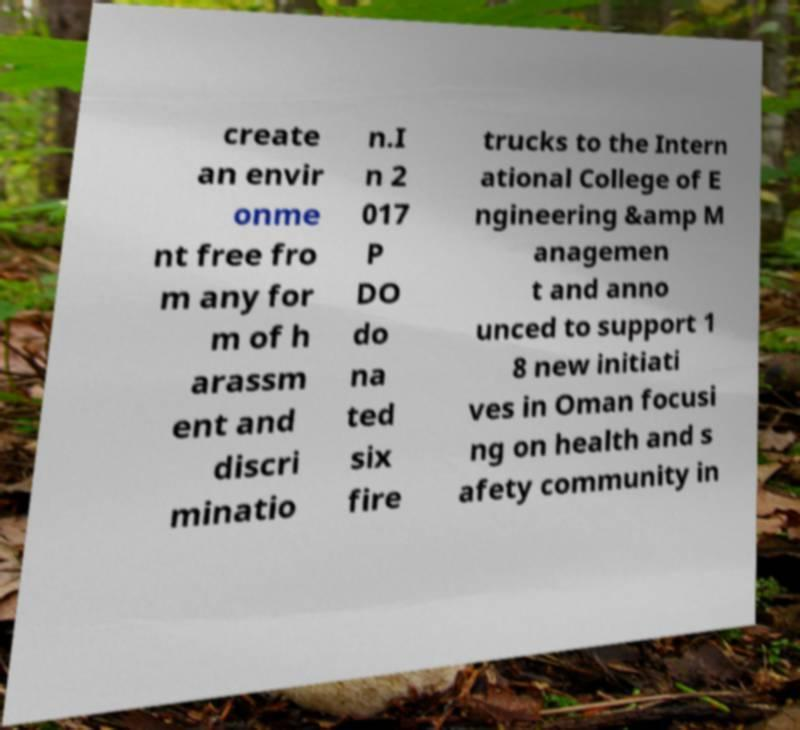There's text embedded in this image that I need extracted. Can you transcribe it verbatim? create an envir onme nt free fro m any for m of h arassm ent and discri minatio n.I n 2 017 P DO do na ted six fire trucks to the Intern ational College of E ngineering &amp M anagemen t and anno unced to support 1 8 new initiati ves in Oman focusi ng on health and s afety community in 